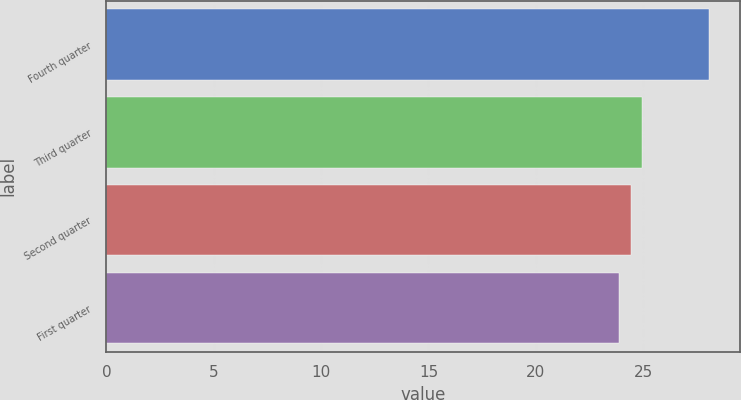<chart> <loc_0><loc_0><loc_500><loc_500><bar_chart><fcel>Fourth quarter<fcel>Third quarter<fcel>Second quarter<fcel>First quarter<nl><fcel>28.09<fcel>24.95<fcel>24.45<fcel>23.9<nl></chart> 